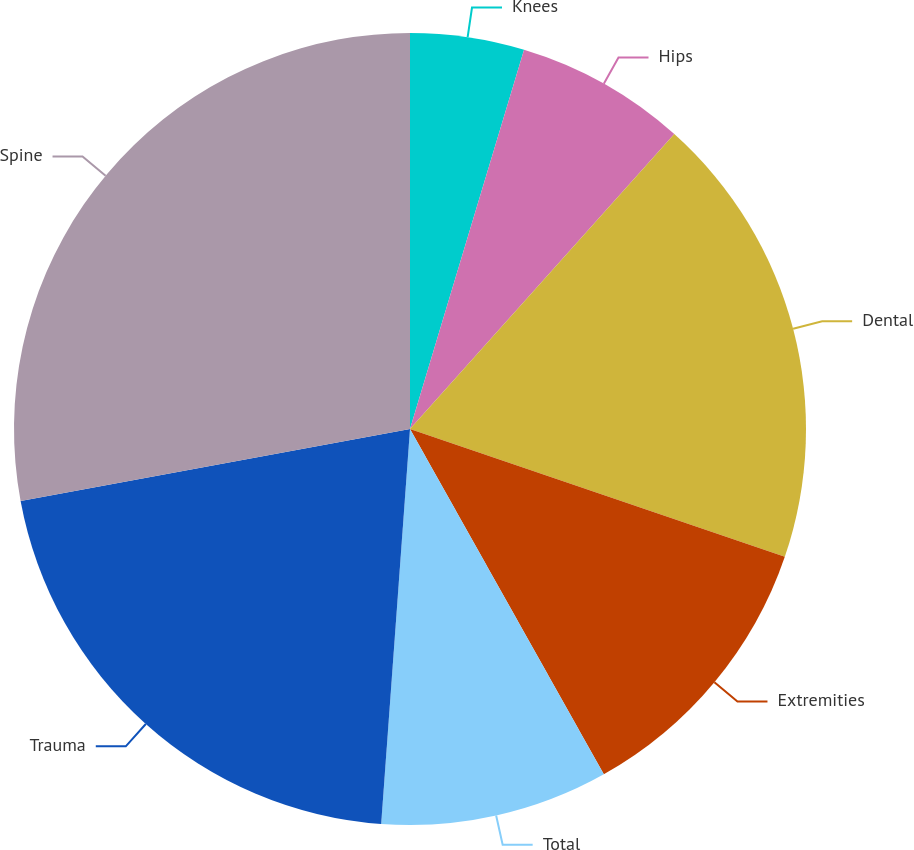Convert chart. <chart><loc_0><loc_0><loc_500><loc_500><pie_chart><fcel>Knees<fcel>Hips<fcel>Dental<fcel>Extremities<fcel>Total<fcel>Trauma<fcel>Spine<nl><fcel>4.65%<fcel>6.98%<fcel>18.6%<fcel>11.63%<fcel>9.3%<fcel>20.93%<fcel>27.91%<nl></chart> 